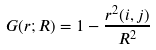<formula> <loc_0><loc_0><loc_500><loc_500>G ( r ; R ) = 1 - \frac { r ^ { 2 } ( i , j ) } { R ^ { 2 } }</formula> 